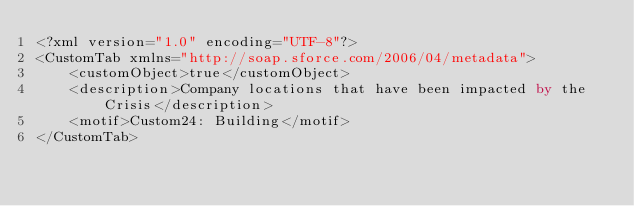Convert code to text. <code><loc_0><loc_0><loc_500><loc_500><_SQL_><?xml version="1.0" encoding="UTF-8"?>
<CustomTab xmlns="http://soap.sforce.com/2006/04/metadata">
    <customObject>true</customObject>
    <description>Company locations that have been impacted by the Crisis</description>
    <motif>Custom24: Building</motif>
</CustomTab>
</code> 